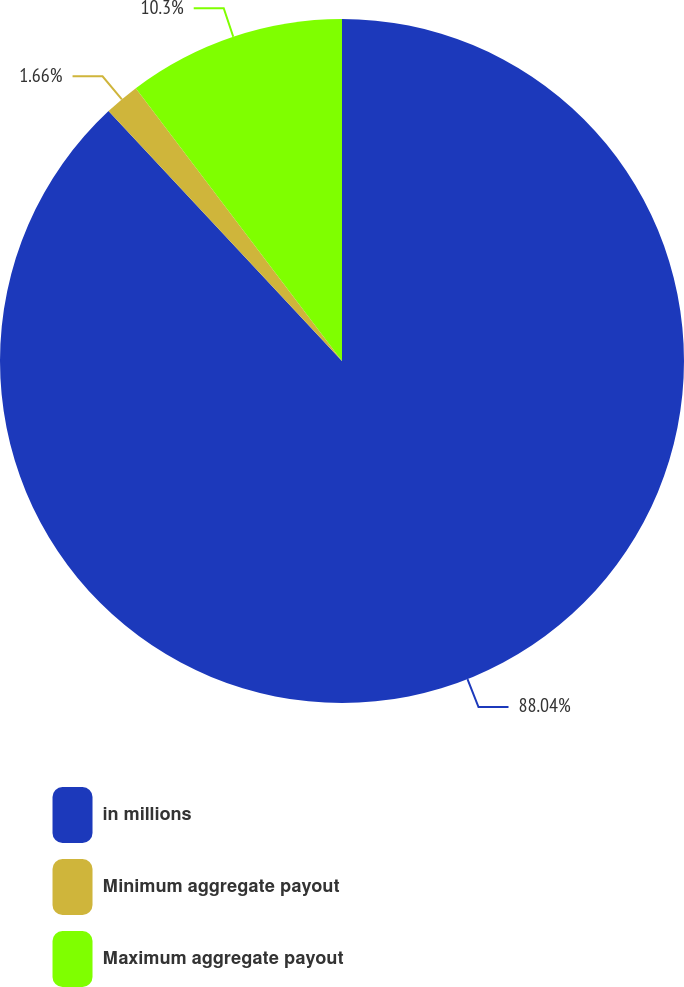Convert chart to OTSL. <chart><loc_0><loc_0><loc_500><loc_500><pie_chart><fcel>in millions<fcel>Minimum aggregate payout<fcel>Maximum aggregate payout<nl><fcel>88.04%<fcel>1.66%<fcel>10.3%<nl></chart> 